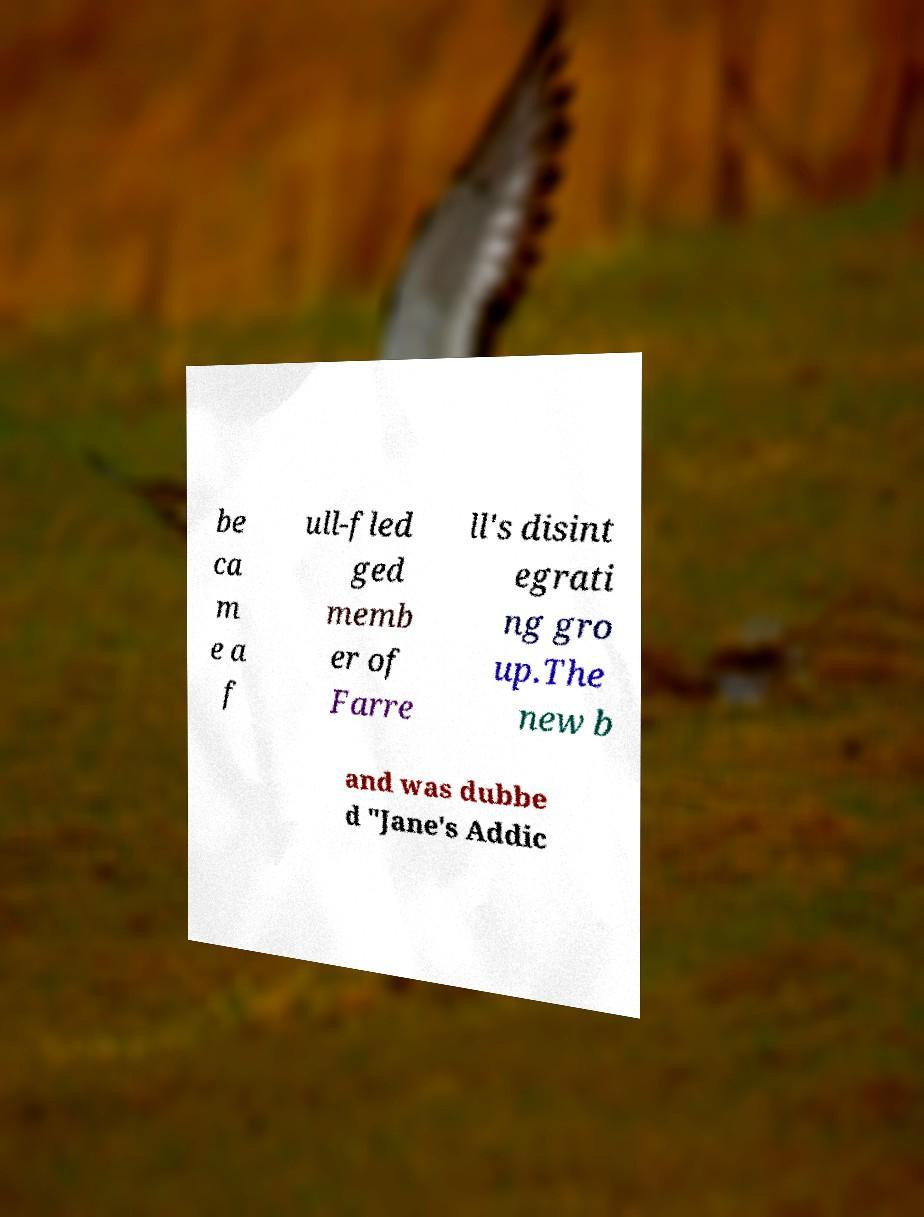For documentation purposes, I need the text within this image transcribed. Could you provide that? be ca m e a f ull-fled ged memb er of Farre ll's disint egrati ng gro up.The new b and was dubbe d "Jane's Addic 